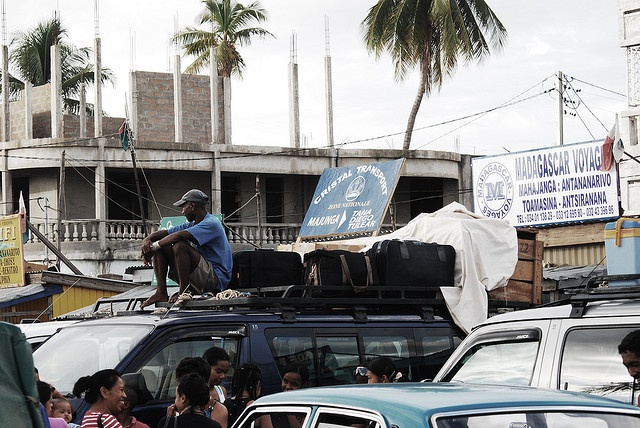Describe the objects in this image and their specific colors. I can see car in white, black, lightgray, and purple tones, car in white, lightgray, black, darkgray, and gray tones, car in white, lightgray, black, darkgray, and gray tones, people in white, black, gray, navy, and darkblue tones, and suitcase in white, black, gray, and darkgray tones in this image. 